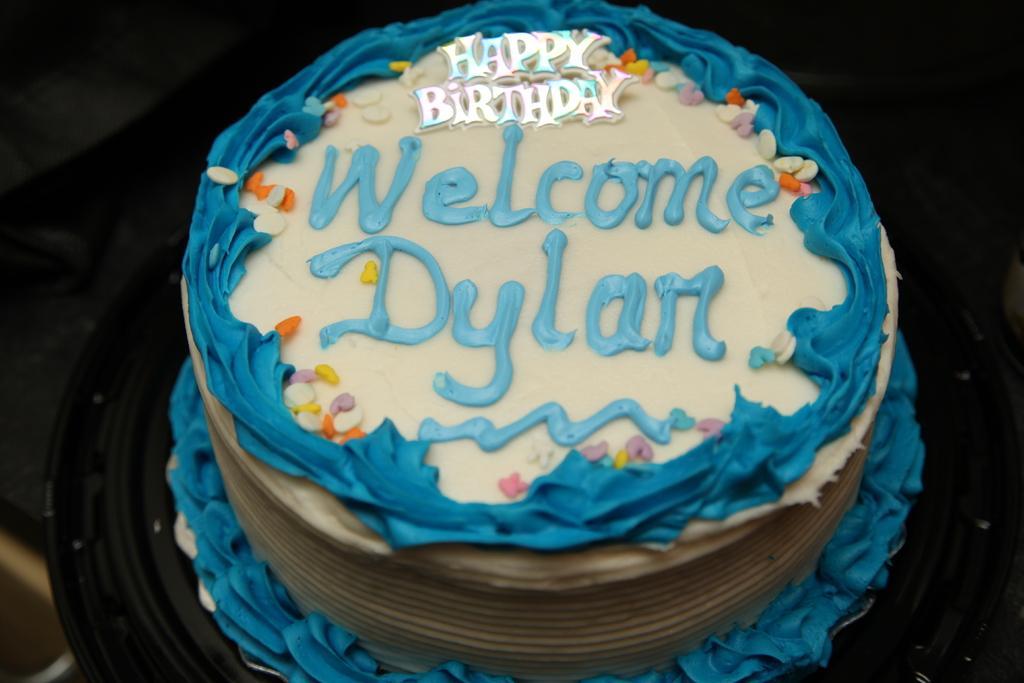Please provide a concise description of this image. In this image we can see a cake with some text and the background is dark. 